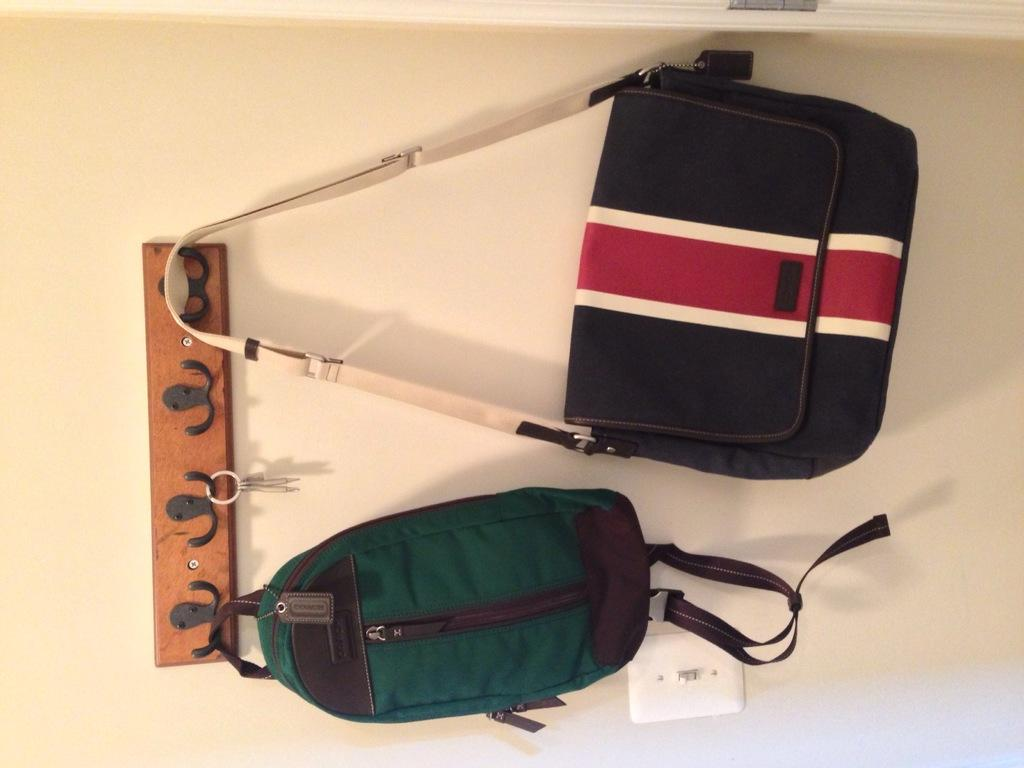What is located in the middle of the image? There is a wall in the middle of the image. What is on the wall? There is a stand on the wall. What items are on the stand? There are keys, a backpack, and a handbag on the stand. What type of hair can be seen on the wall in the image? There is no hair visible on the wall in the image. What kind of marble is used to construct the wall in the image? The image does not provide information about the material used to construct the wall. 